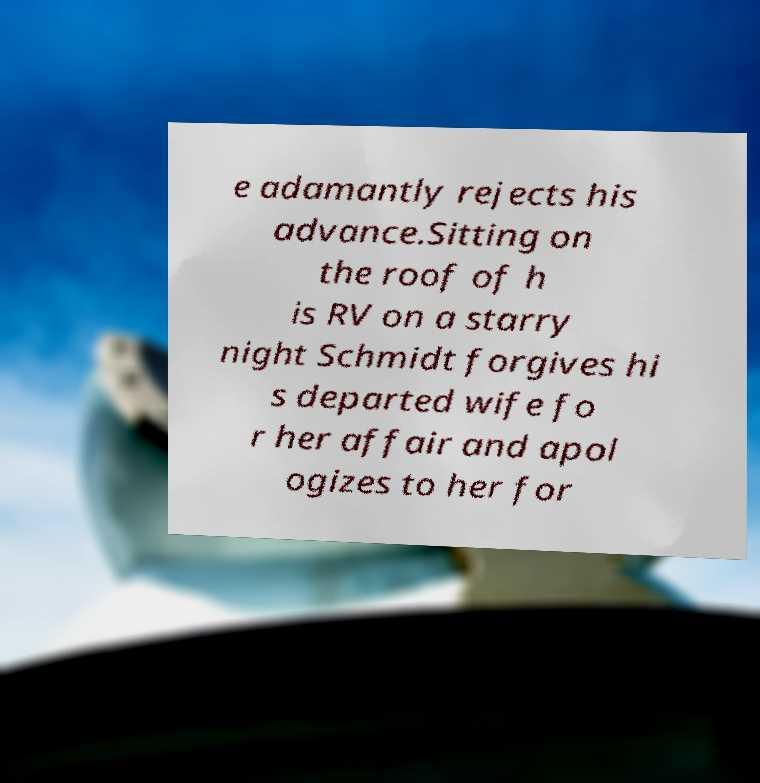I need the written content from this picture converted into text. Can you do that? e adamantly rejects his advance.Sitting on the roof of h is RV on a starry night Schmidt forgives hi s departed wife fo r her affair and apol ogizes to her for 